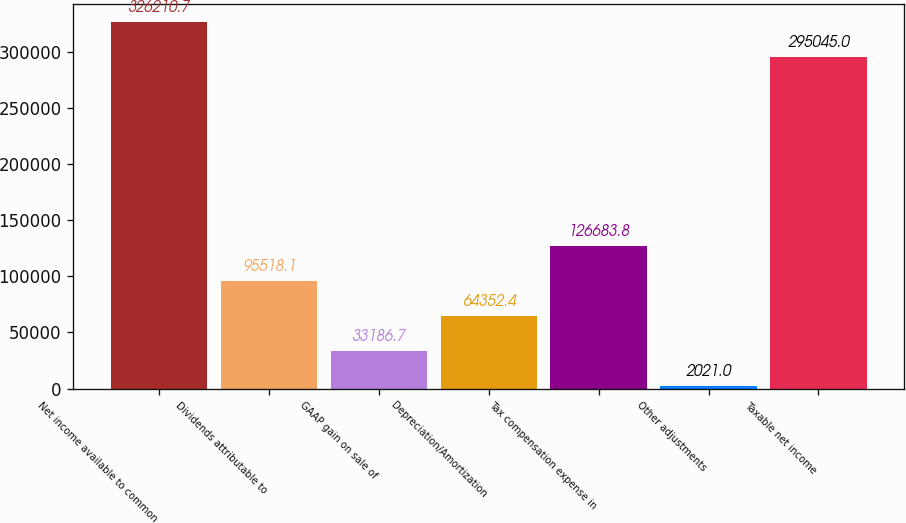Convert chart. <chart><loc_0><loc_0><loc_500><loc_500><bar_chart><fcel>Net income available to common<fcel>Dividends attributable to<fcel>GAAP gain on sale of<fcel>Depreciation/Amortization<fcel>Tax compensation expense in<fcel>Other adjustments<fcel>Taxable net income<nl><fcel>326211<fcel>95518.1<fcel>33186.7<fcel>64352.4<fcel>126684<fcel>2021<fcel>295045<nl></chart> 